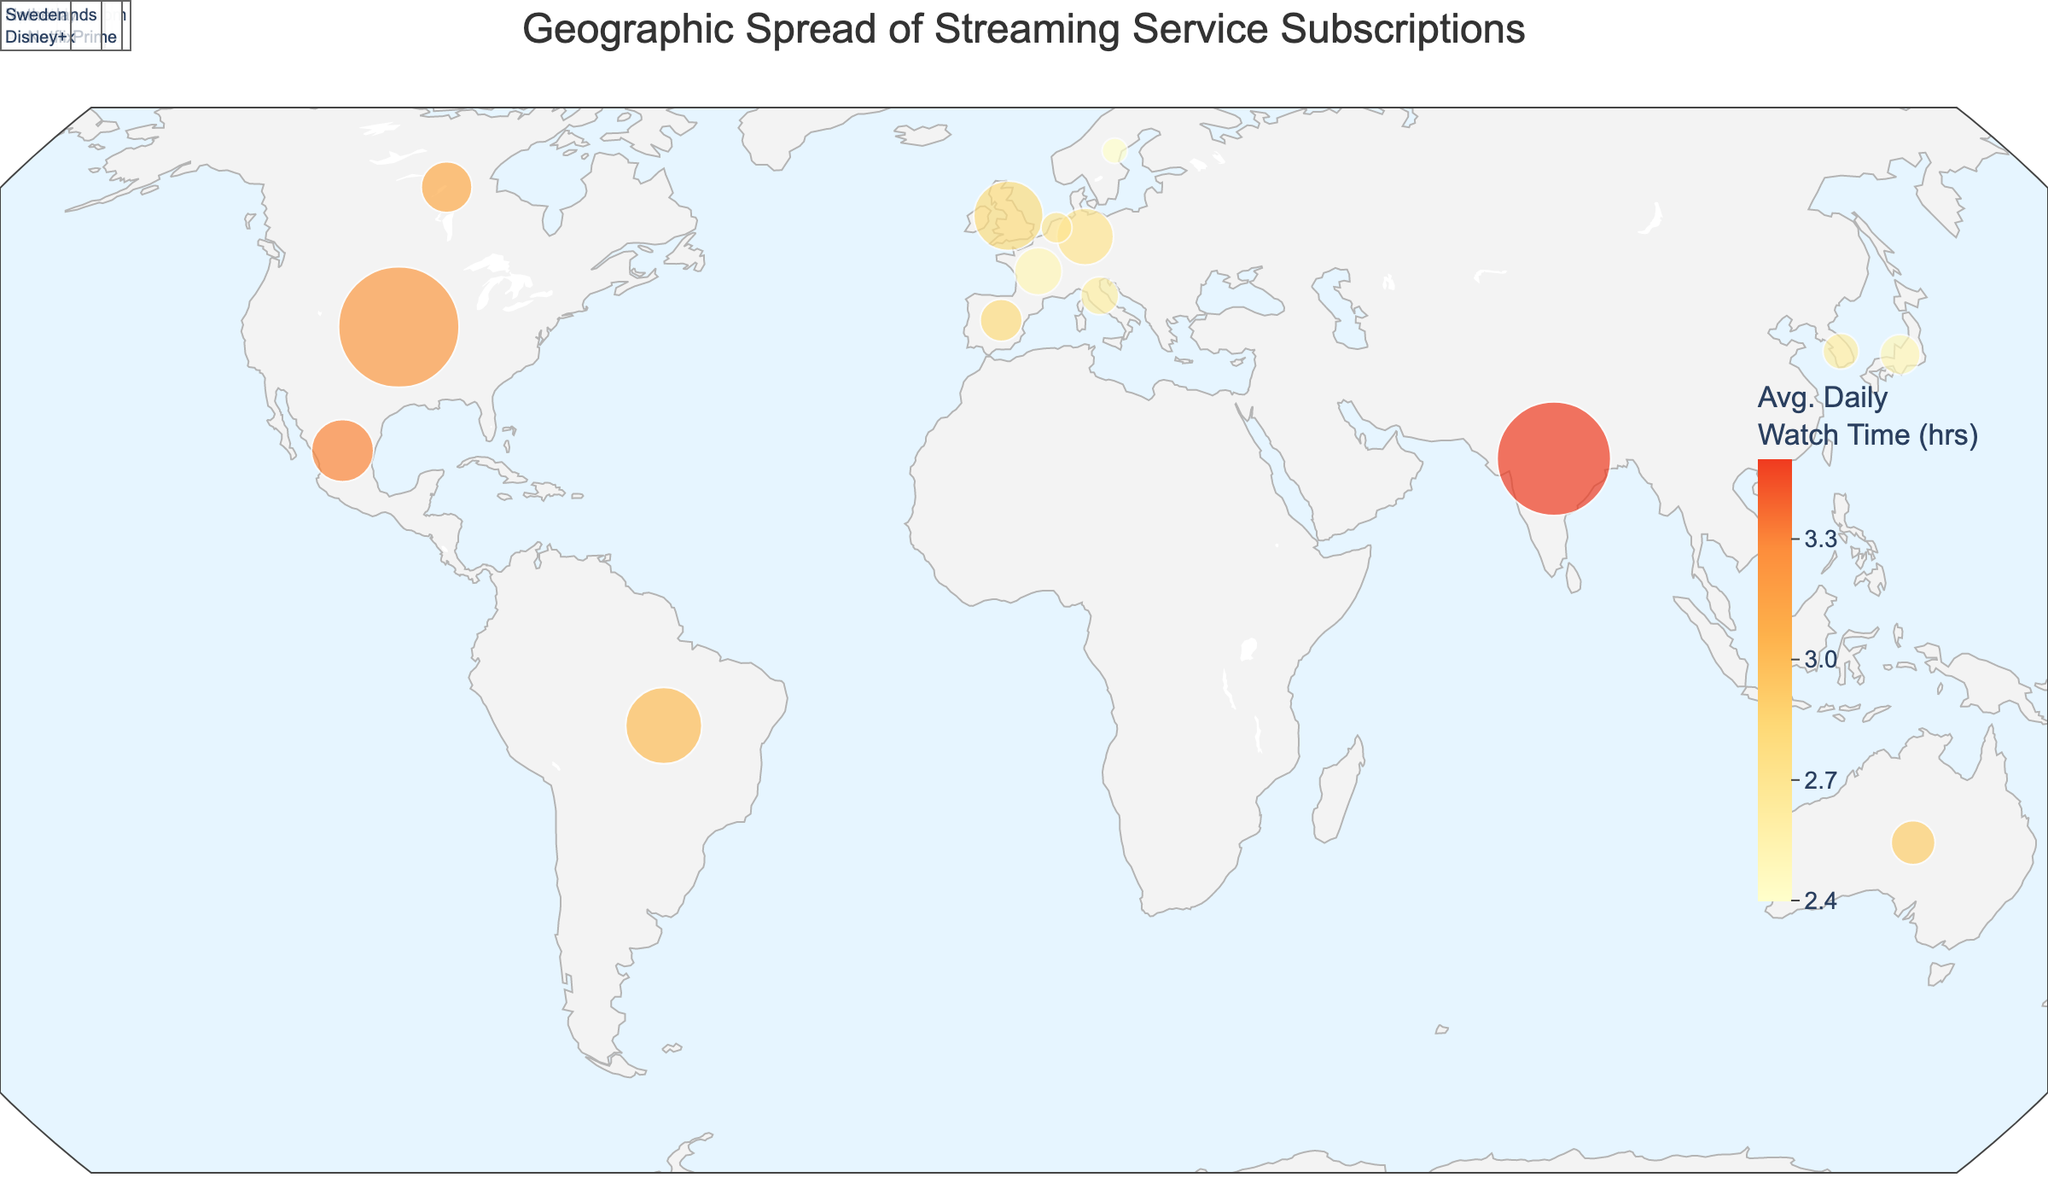What's the average daily watch time in the United States? By looking at the hover data on the figure for the United States, we see that the average daily watch time is displayed.
Answer: 3.2 Which country has the highest number of subscribers for Netflix? By comparing the subscriber counts of Netflix in different countries (United States, Japan, Brazil, South Korea, Canada, Spain, and Netherlands), we find that the United States has the highest number of subscribers with 45,000,000.
Answer: United States What is the peak viewing time in Tokyo, Japan? Referring to the hover data over Tokyo, Japan, the figure shows the peak viewing time.
Answer: 22:00 Which country has the earliest peak viewing time among Disney+ users? By comparing the peak viewing times for Disney+ across India, Australia, and Mexico, the earliest time is observed in Australia at 19:00.
Answer: Australia What is the average daily watch time of Amazon Prime users in Berlin, Germany? Hovering over Berlin, Germany on the figure, the average daily watch time for Amazon Prime users is displayed.
Answer: 2.7 Which country in the dataset has the lowest average daily watch time? By looking at the color gradient representing average daily watch times, we can identify Sweden (2.4 hours) as having the lowest value.
Answer: Sweden Among the listed countries, which Netflix user base has the latest peak viewing time? By checking the peak viewing times for Netflix in different countries, we find that the latest time is in Seoul, South Korea at 23:00.
Answer: South Korea How many countries have a peak viewing time of 21:00? Identifying peak viewing times of 21:00 in the figure, we see that there are three countries: United States, Germany, and Italy.
Answer: 3 Compare the number of Amazon Prime subscribers in London, United Kingdom to those in Berlin, Germany. Which one is higher and by how much? London has 15,000,000 subscribers while Berlin has 10,000,000. The difference is 5,000,000, with London having more subscribers.
Answer: London by 5,000,000 What is the total number of Disney+ subscribers across all listed regions? Summing up the subscribers in Mumbai, Sydney, and Mexico City, we get 40,000,000 + 6,000,000 + 12,000,000 = 58,000,000.
Answer: 58,000,000 